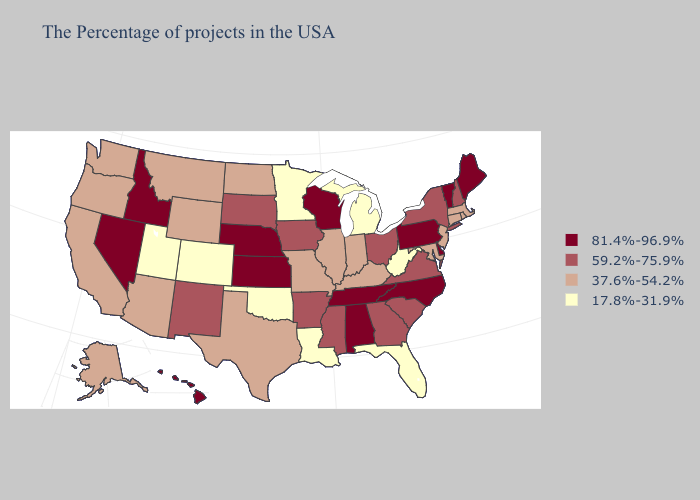Among the states that border Delaware , does Maryland have the lowest value?
Keep it brief. Yes. What is the lowest value in states that border Washington?
Short answer required. 37.6%-54.2%. What is the highest value in the Northeast ?
Give a very brief answer. 81.4%-96.9%. Which states hav the highest value in the West?
Give a very brief answer. Idaho, Nevada, Hawaii. What is the value of New York?
Quick response, please. 59.2%-75.9%. What is the highest value in states that border Washington?
Quick response, please. 81.4%-96.9%. Does Florida have the lowest value in the USA?
Keep it brief. Yes. What is the value of Rhode Island?
Write a very short answer. 37.6%-54.2%. Among the states that border Arkansas , does Texas have the lowest value?
Concise answer only. No. Name the states that have a value in the range 59.2%-75.9%?
Short answer required. New Hampshire, New York, Virginia, South Carolina, Ohio, Georgia, Mississippi, Arkansas, Iowa, South Dakota, New Mexico. Does Alabama have the highest value in the USA?
Keep it brief. Yes. How many symbols are there in the legend?
Answer briefly. 4. Is the legend a continuous bar?
Short answer required. No. What is the value of Kentucky?
Be succinct. 37.6%-54.2%. Name the states that have a value in the range 17.8%-31.9%?
Answer briefly. West Virginia, Florida, Michigan, Louisiana, Minnesota, Oklahoma, Colorado, Utah. 